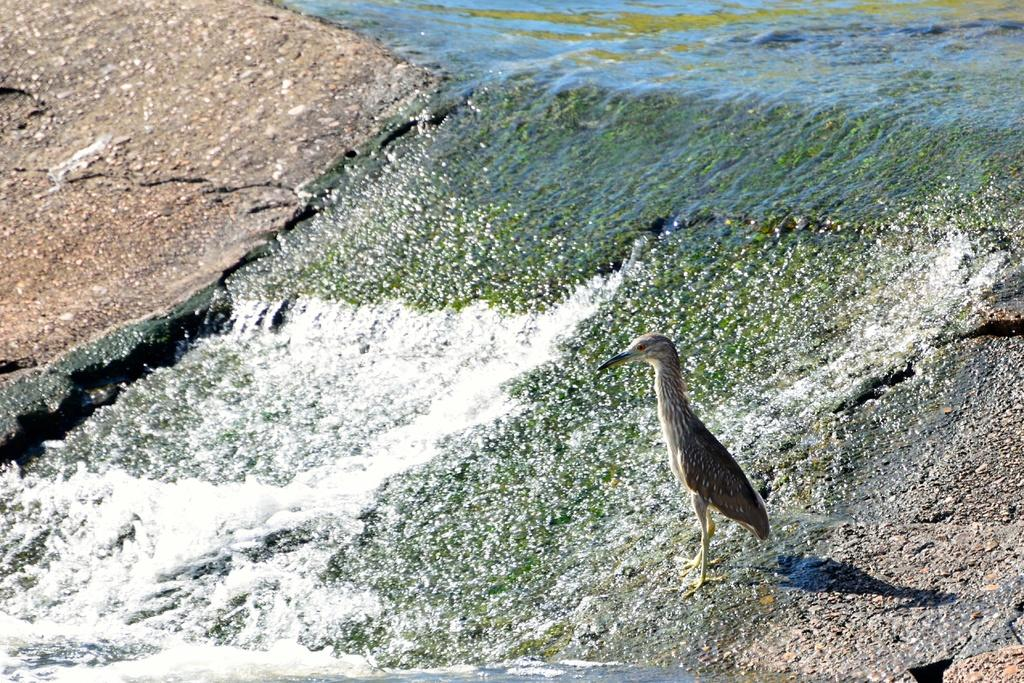What type of animal can be seen on the right side of the image? There is a bird on the right side of the image. What is happening to the stone in the image? Water is flowing over a stone in the image. What type of cable can be seen in the image? There is no cable present in the image. How many frogs are visible in the image? There are no frogs present in the image. 